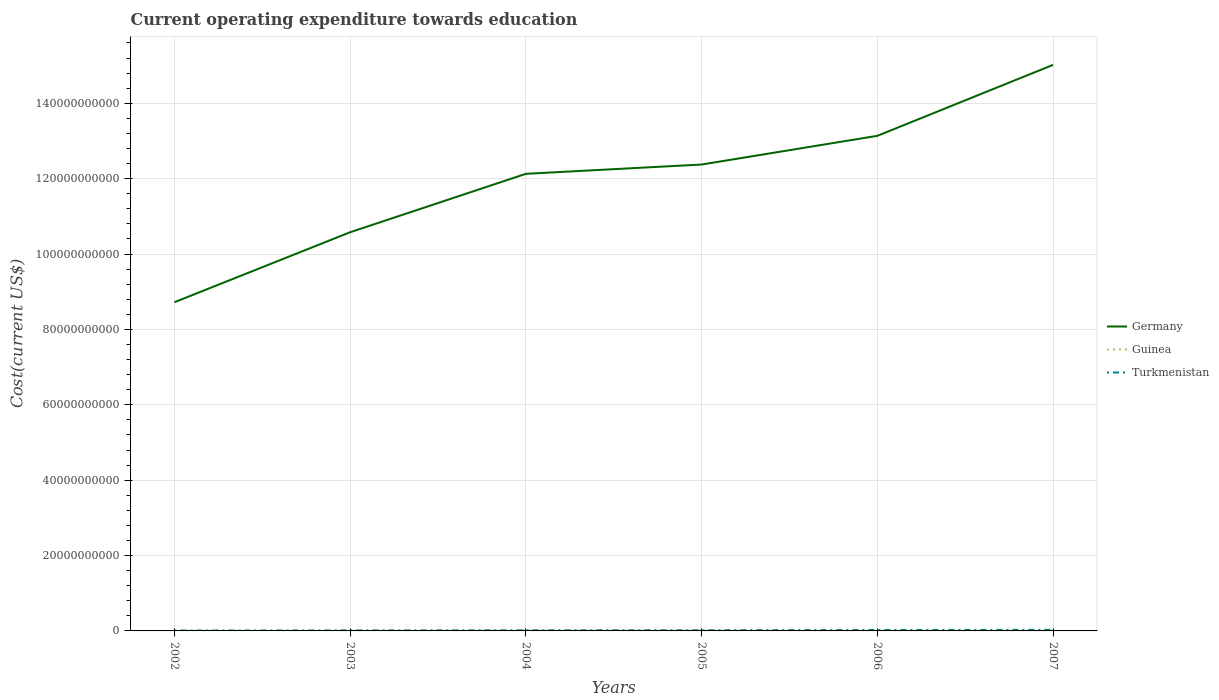How many different coloured lines are there?
Give a very brief answer. 3. Does the line corresponding to Turkmenistan intersect with the line corresponding to Guinea?
Provide a succinct answer. No. Is the number of lines equal to the number of legend labels?
Your answer should be compact. Yes. Across all years, what is the maximum expenditure towards education in Germany?
Your answer should be compact. 8.72e+1. In which year was the expenditure towards education in Germany maximum?
Provide a succinct answer. 2002. What is the total expenditure towards education in Germany in the graph?
Keep it short and to the point. -1.80e+1. What is the difference between the highest and the second highest expenditure towards education in Germany?
Your response must be concise. 6.30e+1. What is the difference between the highest and the lowest expenditure towards education in Germany?
Make the answer very short. 4. Is the expenditure towards education in Turkmenistan strictly greater than the expenditure towards education in Germany over the years?
Offer a terse response. Yes. What is the difference between two consecutive major ticks on the Y-axis?
Give a very brief answer. 2.00e+1. Are the values on the major ticks of Y-axis written in scientific E-notation?
Provide a short and direct response. No. How many legend labels are there?
Provide a short and direct response. 3. What is the title of the graph?
Your answer should be very brief. Current operating expenditure towards education. Does "Fragile and conflict affected situations" appear as one of the legend labels in the graph?
Provide a short and direct response. No. What is the label or title of the Y-axis?
Offer a terse response. Cost(current US$). What is the Cost(current US$) of Germany in 2002?
Offer a very short reply. 8.72e+1. What is the Cost(current US$) in Guinea in 2002?
Your response must be concise. 7.00e+07. What is the Cost(current US$) in Turkmenistan in 2002?
Make the answer very short. 1.01e+08. What is the Cost(current US$) in Germany in 2003?
Your answer should be very brief. 1.06e+11. What is the Cost(current US$) in Guinea in 2003?
Ensure brevity in your answer.  7.36e+07. What is the Cost(current US$) of Turkmenistan in 2003?
Your answer should be compact. 1.37e+08. What is the Cost(current US$) in Germany in 2004?
Provide a short and direct response. 1.21e+11. What is the Cost(current US$) of Guinea in 2004?
Your answer should be compact. 7.48e+07. What is the Cost(current US$) of Turkmenistan in 2004?
Ensure brevity in your answer.  1.56e+08. What is the Cost(current US$) in Germany in 2005?
Your answer should be very brief. 1.24e+11. What is the Cost(current US$) of Guinea in 2005?
Offer a very short reply. 5.59e+07. What is the Cost(current US$) in Turkmenistan in 2005?
Your answer should be very brief. 1.75e+08. What is the Cost(current US$) in Germany in 2006?
Offer a terse response. 1.31e+11. What is the Cost(current US$) in Guinea in 2006?
Your response must be concise. 5.20e+07. What is the Cost(current US$) of Turkmenistan in 2006?
Keep it short and to the point. 2.32e+08. What is the Cost(current US$) of Germany in 2007?
Your response must be concise. 1.50e+11. What is the Cost(current US$) of Guinea in 2007?
Make the answer very short. 7.18e+07. What is the Cost(current US$) in Turkmenistan in 2007?
Provide a succinct answer. 2.86e+08. Across all years, what is the maximum Cost(current US$) in Germany?
Your answer should be very brief. 1.50e+11. Across all years, what is the maximum Cost(current US$) of Guinea?
Provide a succinct answer. 7.48e+07. Across all years, what is the maximum Cost(current US$) of Turkmenistan?
Your answer should be very brief. 2.86e+08. Across all years, what is the minimum Cost(current US$) in Germany?
Your answer should be very brief. 8.72e+1. Across all years, what is the minimum Cost(current US$) of Guinea?
Your answer should be very brief. 5.20e+07. Across all years, what is the minimum Cost(current US$) of Turkmenistan?
Your response must be concise. 1.01e+08. What is the total Cost(current US$) of Germany in the graph?
Offer a very short reply. 7.20e+11. What is the total Cost(current US$) in Guinea in the graph?
Offer a terse response. 3.98e+08. What is the total Cost(current US$) of Turkmenistan in the graph?
Keep it short and to the point. 1.09e+09. What is the difference between the Cost(current US$) of Germany in 2002 and that in 2003?
Your answer should be compact. -1.86e+1. What is the difference between the Cost(current US$) of Guinea in 2002 and that in 2003?
Your answer should be compact. -3.61e+06. What is the difference between the Cost(current US$) in Turkmenistan in 2002 and that in 2003?
Your answer should be very brief. -3.62e+07. What is the difference between the Cost(current US$) of Germany in 2002 and that in 2004?
Give a very brief answer. -3.41e+1. What is the difference between the Cost(current US$) of Guinea in 2002 and that in 2004?
Offer a terse response. -4.74e+06. What is the difference between the Cost(current US$) in Turkmenistan in 2002 and that in 2004?
Make the answer very short. -5.55e+07. What is the difference between the Cost(current US$) of Germany in 2002 and that in 2005?
Ensure brevity in your answer.  -3.65e+1. What is the difference between the Cost(current US$) in Guinea in 2002 and that in 2005?
Your response must be concise. 1.41e+07. What is the difference between the Cost(current US$) of Turkmenistan in 2002 and that in 2005?
Your answer should be compact. -7.43e+07. What is the difference between the Cost(current US$) of Germany in 2002 and that in 2006?
Your response must be concise. -4.41e+1. What is the difference between the Cost(current US$) in Guinea in 2002 and that in 2006?
Your answer should be compact. 1.80e+07. What is the difference between the Cost(current US$) in Turkmenistan in 2002 and that in 2006?
Keep it short and to the point. -1.31e+08. What is the difference between the Cost(current US$) in Germany in 2002 and that in 2007?
Give a very brief answer. -6.30e+1. What is the difference between the Cost(current US$) in Guinea in 2002 and that in 2007?
Provide a succinct answer. -1.75e+06. What is the difference between the Cost(current US$) of Turkmenistan in 2002 and that in 2007?
Provide a short and direct response. -1.85e+08. What is the difference between the Cost(current US$) in Germany in 2003 and that in 2004?
Give a very brief answer. -1.55e+1. What is the difference between the Cost(current US$) of Guinea in 2003 and that in 2004?
Keep it short and to the point. -1.13e+06. What is the difference between the Cost(current US$) in Turkmenistan in 2003 and that in 2004?
Keep it short and to the point. -1.93e+07. What is the difference between the Cost(current US$) of Germany in 2003 and that in 2005?
Offer a very short reply. -1.80e+1. What is the difference between the Cost(current US$) in Guinea in 2003 and that in 2005?
Keep it short and to the point. 1.77e+07. What is the difference between the Cost(current US$) in Turkmenistan in 2003 and that in 2005?
Give a very brief answer. -3.81e+07. What is the difference between the Cost(current US$) in Germany in 2003 and that in 2006?
Offer a very short reply. -2.56e+1. What is the difference between the Cost(current US$) of Guinea in 2003 and that in 2006?
Provide a succinct answer. 2.16e+07. What is the difference between the Cost(current US$) of Turkmenistan in 2003 and that in 2006?
Give a very brief answer. -9.46e+07. What is the difference between the Cost(current US$) in Germany in 2003 and that in 2007?
Your answer should be very brief. -4.44e+1. What is the difference between the Cost(current US$) in Guinea in 2003 and that in 2007?
Your response must be concise. 1.86e+06. What is the difference between the Cost(current US$) of Turkmenistan in 2003 and that in 2007?
Your answer should be very brief. -1.49e+08. What is the difference between the Cost(current US$) in Germany in 2004 and that in 2005?
Make the answer very short. -2.46e+09. What is the difference between the Cost(current US$) in Guinea in 2004 and that in 2005?
Keep it short and to the point. 1.88e+07. What is the difference between the Cost(current US$) of Turkmenistan in 2004 and that in 2005?
Your answer should be very brief. -1.88e+07. What is the difference between the Cost(current US$) in Germany in 2004 and that in 2006?
Your response must be concise. -1.01e+1. What is the difference between the Cost(current US$) of Guinea in 2004 and that in 2006?
Provide a short and direct response. 2.28e+07. What is the difference between the Cost(current US$) in Turkmenistan in 2004 and that in 2006?
Give a very brief answer. -7.53e+07. What is the difference between the Cost(current US$) in Germany in 2004 and that in 2007?
Provide a succinct answer. -2.89e+1. What is the difference between the Cost(current US$) of Guinea in 2004 and that in 2007?
Keep it short and to the point. 2.99e+06. What is the difference between the Cost(current US$) of Turkmenistan in 2004 and that in 2007?
Your answer should be very brief. -1.29e+08. What is the difference between the Cost(current US$) in Germany in 2005 and that in 2006?
Your answer should be compact. -7.61e+09. What is the difference between the Cost(current US$) in Guinea in 2005 and that in 2006?
Your answer should be compact. 3.90e+06. What is the difference between the Cost(current US$) of Turkmenistan in 2005 and that in 2006?
Give a very brief answer. -5.65e+07. What is the difference between the Cost(current US$) of Germany in 2005 and that in 2007?
Give a very brief answer. -2.64e+1. What is the difference between the Cost(current US$) of Guinea in 2005 and that in 2007?
Provide a succinct answer. -1.59e+07. What is the difference between the Cost(current US$) in Turkmenistan in 2005 and that in 2007?
Provide a succinct answer. -1.10e+08. What is the difference between the Cost(current US$) in Germany in 2006 and that in 2007?
Offer a very short reply. -1.88e+1. What is the difference between the Cost(current US$) of Guinea in 2006 and that in 2007?
Your answer should be very brief. -1.98e+07. What is the difference between the Cost(current US$) in Turkmenistan in 2006 and that in 2007?
Provide a succinct answer. -5.39e+07. What is the difference between the Cost(current US$) of Germany in 2002 and the Cost(current US$) of Guinea in 2003?
Your answer should be compact. 8.71e+1. What is the difference between the Cost(current US$) in Germany in 2002 and the Cost(current US$) in Turkmenistan in 2003?
Your response must be concise. 8.71e+1. What is the difference between the Cost(current US$) of Guinea in 2002 and the Cost(current US$) of Turkmenistan in 2003?
Provide a short and direct response. -6.69e+07. What is the difference between the Cost(current US$) in Germany in 2002 and the Cost(current US$) in Guinea in 2004?
Your response must be concise. 8.71e+1. What is the difference between the Cost(current US$) of Germany in 2002 and the Cost(current US$) of Turkmenistan in 2004?
Offer a very short reply. 8.71e+1. What is the difference between the Cost(current US$) of Guinea in 2002 and the Cost(current US$) of Turkmenistan in 2004?
Your answer should be compact. -8.62e+07. What is the difference between the Cost(current US$) in Germany in 2002 and the Cost(current US$) in Guinea in 2005?
Your response must be concise. 8.72e+1. What is the difference between the Cost(current US$) of Germany in 2002 and the Cost(current US$) of Turkmenistan in 2005?
Give a very brief answer. 8.70e+1. What is the difference between the Cost(current US$) in Guinea in 2002 and the Cost(current US$) in Turkmenistan in 2005?
Your answer should be compact. -1.05e+08. What is the difference between the Cost(current US$) of Germany in 2002 and the Cost(current US$) of Guinea in 2006?
Offer a terse response. 8.72e+1. What is the difference between the Cost(current US$) in Germany in 2002 and the Cost(current US$) in Turkmenistan in 2006?
Keep it short and to the point. 8.70e+1. What is the difference between the Cost(current US$) in Guinea in 2002 and the Cost(current US$) in Turkmenistan in 2006?
Ensure brevity in your answer.  -1.62e+08. What is the difference between the Cost(current US$) in Germany in 2002 and the Cost(current US$) in Guinea in 2007?
Offer a terse response. 8.72e+1. What is the difference between the Cost(current US$) in Germany in 2002 and the Cost(current US$) in Turkmenistan in 2007?
Keep it short and to the point. 8.69e+1. What is the difference between the Cost(current US$) of Guinea in 2002 and the Cost(current US$) of Turkmenistan in 2007?
Your response must be concise. -2.16e+08. What is the difference between the Cost(current US$) of Germany in 2003 and the Cost(current US$) of Guinea in 2004?
Ensure brevity in your answer.  1.06e+11. What is the difference between the Cost(current US$) in Germany in 2003 and the Cost(current US$) in Turkmenistan in 2004?
Make the answer very short. 1.06e+11. What is the difference between the Cost(current US$) in Guinea in 2003 and the Cost(current US$) in Turkmenistan in 2004?
Offer a terse response. -8.26e+07. What is the difference between the Cost(current US$) of Germany in 2003 and the Cost(current US$) of Guinea in 2005?
Your answer should be compact. 1.06e+11. What is the difference between the Cost(current US$) in Germany in 2003 and the Cost(current US$) in Turkmenistan in 2005?
Provide a succinct answer. 1.06e+11. What is the difference between the Cost(current US$) of Guinea in 2003 and the Cost(current US$) of Turkmenistan in 2005?
Offer a terse response. -1.01e+08. What is the difference between the Cost(current US$) of Germany in 2003 and the Cost(current US$) of Guinea in 2006?
Offer a terse response. 1.06e+11. What is the difference between the Cost(current US$) in Germany in 2003 and the Cost(current US$) in Turkmenistan in 2006?
Offer a very short reply. 1.06e+11. What is the difference between the Cost(current US$) in Guinea in 2003 and the Cost(current US$) in Turkmenistan in 2006?
Provide a short and direct response. -1.58e+08. What is the difference between the Cost(current US$) of Germany in 2003 and the Cost(current US$) of Guinea in 2007?
Offer a terse response. 1.06e+11. What is the difference between the Cost(current US$) in Germany in 2003 and the Cost(current US$) in Turkmenistan in 2007?
Make the answer very short. 1.06e+11. What is the difference between the Cost(current US$) of Guinea in 2003 and the Cost(current US$) of Turkmenistan in 2007?
Provide a short and direct response. -2.12e+08. What is the difference between the Cost(current US$) in Germany in 2004 and the Cost(current US$) in Guinea in 2005?
Your answer should be very brief. 1.21e+11. What is the difference between the Cost(current US$) of Germany in 2004 and the Cost(current US$) of Turkmenistan in 2005?
Your answer should be very brief. 1.21e+11. What is the difference between the Cost(current US$) in Guinea in 2004 and the Cost(current US$) in Turkmenistan in 2005?
Offer a very short reply. -1.00e+08. What is the difference between the Cost(current US$) of Germany in 2004 and the Cost(current US$) of Guinea in 2006?
Give a very brief answer. 1.21e+11. What is the difference between the Cost(current US$) in Germany in 2004 and the Cost(current US$) in Turkmenistan in 2006?
Make the answer very short. 1.21e+11. What is the difference between the Cost(current US$) of Guinea in 2004 and the Cost(current US$) of Turkmenistan in 2006?
Ensure brevity in your answer.  -1.57e+08. What is the difference between the Cost(current US$) of Germany in 2004 and the Cost(current US$) of Guinea in 2007?
Offer a terse response. 1.21e+11. What is the difference between the Cost(current US$) of Germany in 2004 and the Cost(current US$) of Turkmenistan in 2007?
Make the answer very short. 1.21e+11. What is the difference between the Cost(current US$) in Guinea in 2004 and the Cost(current US$) in Turkmenistan in 2007?
Your answer should be compact. -2.11e+08. What is the difference between the Cost(current US$) in Germany in 2005 and the Cost(current US$) in Guinea in 2006?
Offer a terse response. 1.24e+11. What is the difference between the Cost(current US$) in Germany in 2005 and the Cost(current US$) in Turkmenistan in 2006?
Offer a terse response. 1.24e+11. What is the difference between the Cost(current US$) of Guinea in 2005 and the Cost(current US$) of Turkmenistan in 2006?
Make the answer very short. -1.76e+08. What is the difference between the Cost(current US$) of Germany in 2005 and the Cost(current US$) of Guinea in 2007?
Provide a short and direct response. 1.24e+11. What is the difference between the Cost(current US$) in Germany in 2005 and the Cost(current US$) in Turkmenistan in 2007?
Offer a terse response. 1.23e+11. What is the difference between the Cost(current US$) in Guinea in 2005 and the Cost(current US$) in Turkmenistan in 2007?
Offer a terse response. -2.30e+08. What is the difference between the Cost(current US$) of Germany in 2006 and the Cost(current US$) of Guinea in 2007?
Offer a terse response. 1.31e+11. What is the difference between the Cost(current US$) of Germany in 2006 and the Cost(current US$) of Turkmenistan in 2007?
Keep it short and to the point. 1.31e+11. What is the difference between the Cost(current US$) in Guinea in 2006 and the Cost(current US$) in Turkmenistan in 2007?
Give a very brief answer. -2.34e+08. What is the average Cost(current US$) of Germany per year?
Provide a succinct answer. 1.20e+11. What is the average Cost(current US$) in Guinea per year?
Provide a succinct answer. 6.63e+07. What is the average Cost(current US$) in Turkmenistan per year?
Provide a short and direct response. 1.81e+08. In the year 2002, what is the difference between the Cost(current US$) in Germany and Cost(current US$) in Guinea?
Make the answer very short. 8.72e+1. In the year 2002, what is the difference between the Cost(current US$) in Germany and Cost(current US$) in Turkmenistan?
Provide a succinct answer. 8.71e+1. In the year 2002, what is the difference between the Cost(current US$) of Guinea and Cost(current US$) of Turkmenistan?
Give a very brief answer. -3.07e+07. In the year 2003, what is the difference between the Cost(current US$) in Germany and Cost(current US$) in Guinea?
Your answer should be very brief. 1.06e+11. In the year 2003, what is the difference between the Cost(current US$) of Germany and Cost(current US$) of Turkmenistan?
Provide a succinct answer. 1.06e+11. In the year 2003, what is the difference between the Cost(current US$) in Guinea and Cost(current US$) in Turkmenistan?
Provide a short and direct response. -6.33e+07. In the year 2004, what is the difference between the Cost(current US$) in Germany and Cost(current US$) in Guinea?
Give a very brief answer. 1.21e+11. In the year 2004, what is the difference between the Cost(current US$) of Germany and Cost(current US$) of Turkmenistan?
Give a very brief answer. 1.21e+11. In the year 2004, what is the difference between the Cost(current US$) of Guinea and Cost(current US$) of Turkmenistan?
Provide a succinct answer. -8.15e+07. In the year 2005, what is the difference between the Cost(current US$) of Germany and Cost(current US$) of Guinea?
Your answer should be compact. 1.24e+11. In the year 2005, what is the difference between the Cost(current US$) in Germany and Cost(current US$) in Turkmenistan?
Your answer should be compact. 1.24e+11. In the year 2005, what is the difference between the Cost(current US$) of Guinea and Cost(current US$) of Turkmenistan?
Offer a terse response. -1.19e+08. In the year 2006, what is the difference between the Cost(current US$) of Germany and Cost(current US$) of Guinea?
Provide a succinct answer. 1.31e+11. In the year 2006, what is the difference between the Cost(current US$) of Germany and Cost(current US$) of Turkmenistan?
Ensure brevity in your answer.  1.31e+11. In the year 2006, what is the difference between the Cost(current US$) in Guinea and Cost(current US$) in Turkmenistan?
Provide a short and direct response. -1.80e+08. In the year 2007, what is the difference between the Cost(current US$) of Germany and Cost(current US$) of Guinea?
Offer a very short reply. 1.50e+11. In the year 2007, what is the difference between the Cost(current US$) in Germany and Cost(current US$) in Turkmenistan?
Your answer should be very brief. 1.50e+11. In the year 2007, what is the difference between the Cost(current US$) of Guinea and Cost(current US$) of Turkmenistan?
Keep it short and to the point. -2.14e+08. What is the ratio of the Cost(current US$) of Germany in 2002 to that in 2003?
Your response must be concise. 0.82. What is the ratio of the Cost(current US$) of Guinea in 2002 to that in 2003?
Your response must be concise. 0.95. What is the ratio of the Cost(current US$) of Turkmenistan in 2002 to that in 2003?
Offer a very short reply. 0.74. What is the ratio of the Cost(current US$) in Germany in 2002 to that in 2004?
Offer a very short reply. 0.72. What is the ratio of the Cost(current US$) in Guinea in 2002 to that in 2004?
Your response must be concise. 0.94. What is the ratio of the Cost(current US$) in Turkmenistan in 2002 to that in 2004?
Make the answer very short. 0.64. What is the ratio of the Cost(current US$) in Germany in 2002 to that in 2005?
Make the answer very short. 0.7. What is the ratio of the Cost(current US$) of Guinea in 2002 to that in 2005?
Provide a succinct answer. 1.25. What is the ratio of the Cost(current US$) of Turkmenistan in 2002 to that in 2005?
Keep it short and to the point. 0.58. What is the ratio of the Cost(current US$) in Germany in 2002 to that in 2006?
Ensure brevity in your answer.  0.66. What is the ratio of the Cost(current US$) of Guinea in 2002 to that in 2006?
Provide a succinct answer. 1.35. What is the ratio of the Cost(current US$) of Turkmenistan in 2002 to that in 2006?
Keep it short and to the point. 0.43. What is the ratio of the Cost(current US$) of Germany in 2002 to that in 2007?
Ensure brevity in your answer.  0.58. What is the ratio of the Cost(current US$) in Guinea in 2002 to that in 2007?
Provide a short and direct response. 0.98. What is the ratio of the Cost(current US$) in Turkmenistan in 2002 to that in 2007?
Ensure brevity in your answer.  0.35. What is the ratio of the Cost(current US$) of Germany in 2003 to that in 2004?
Ensure brevity in your answer.  0.87. What is the ratio of the Cost(current US$) in Guinea in 2003 to that in 2004?
Provide a succinct answer. 0.98. What is the ratio of the Cost(current US$) in Turkmenistan in 2003 to that in 2004?
Ensure brevity in your answer.  0.88. What is the ratio of the Cost(current US$) in Germany in 2003 to that in 2005?
Ensure brevity in your answer.  0.85. What is the ratio of the Cost(current US$) in Guinea in 2003 to that in 2005?
Give a very brief answer. 1.32. What is the ratio of the Cost(current US$) in Turkmenistan in 2003 to that in 2005?
Give a very brief answer. 0.78. What is the ratio of the Cost(current US$) in Germany in 2003 to that in 2006?
Offer a terse response. 0.81. What is the ratio of the Cost(current US$) in Guinea in 2003 to that in 2006?
Your answer should be compact. 1.42. What is the ratio of the Cost(current US$) of Turkmenistan in 2003 to that in 2006?
Provide a short and direct response. 0.59. What is the ratio of the Cost(current US$) of Germany in 2003 to that in 2007?
Your answer should be compact. 0.7. What is the ratio of the Cost(current US$) of Guinea in 2003 to that in 2007?
Provide a short and direct response. 1.03. What is the ratio of the Cost(current US$) in Turkmenistan in 2003 to that in 2007?
Give a very brief answer. 0.48. What is the ratio of the Cost(current US$) of Germany in 2004 to that in 2005?
Ensure brevity in your answer.  0.98. What is the ratio of the Cost(current US$) of Guinea in 2004 to that in 2005?
Your answer should be compact. 1.34. What is the ratio of the Cost(current US$) of Turkmenistan in 2004 to that in 2005?
Make the answer very short. 0.89. What is the ratio of the Cost(current US$) of Germany in 2004 to that in 2006?
Give a very brief answer. 0.92. What is the ratio of the Cost(current US$) of Guinea in 2004 to that in 2006?
Make the answer very short. 1.44. What is the ratio of the Cost(current US$) of Turkmenistan in 2004 to that in 2006?
Make the answer very short. 0.67. What is the ratio of the Cost(current US$) of Germany in 2004 to that in 2007?
Provide a short and direct response. 0.81. What is the ratio of the Cost(current US$) of Guinea in 2004 to that in 2007?
Give a very brief answer. 1.04. What is the ratio of the Cost(current US$) of Turkmenistan in 2004 to that in 2007?
Ensure brevity in your answer.  0.55. What is the ratio of the Cost(current US$) in Germany in 2005 to that in 2006?
Your answer should be compact. 0.94. What is the ratio of the Cost(current US$) in Guinea in 2005 to that in 2006?
Provide a succinct answer. 1.08. What is the ratio of the Cost(current US$) of Turkmenistan in 2005 to that in 2006?
Offer a very short reply. 0.76. What is the ratio of the Cost(current US$) in Germany in 2005 to that in 2007?
Your answer should be compact. 0.82. What is the ratio of the Cost(current US$) of Guinea in 2005 to that in 2007?
Your answer should be compact. 0.78. What is the ratio of the Cost(current US$) in Turkmenistan in 2005 to that in 2007?
Give a very brief answer. 0.61. What is the ratio of the Cost(current US$) of Germany in 2006 to that in 2007?
Your response must be concise. 0.87. What is the ratio of the Cost(current US$) in Guinea in 2006 to that in 2007?
Your response must be concise. 0.72. What is the ratio of the Cost(current US$) in Turkmenistan in 2006 to that in 2007?
Provide a short and direct response. 0.81. What is the difference between the highest and the second highest Cost(current US$) of Germany?
Keep it short and to the point. 1.88e+1. What is the difference between the highest and the second highest Cost(current US$) of Guinea?
Your response must be concise. 1.13e+06. What is the difference between the highest and the second highest Cost(current US$) of Turkmenistan?
Make the answer very short. 5.39e+07. What is the difference between the highest and the lowest Cost(current US$) of Germany?
Provide a short and direct response. 6.30e+1. What is the difference between the highest and the lowest Cost(current US$) in Guinea?
Your answer should be compact. 2.28e+07. What is the difference between the highest and the lowest Cost(current US$) of Turkmenistan?
Offer a very short reply. 1.85e+08. 